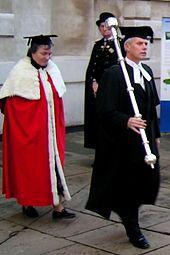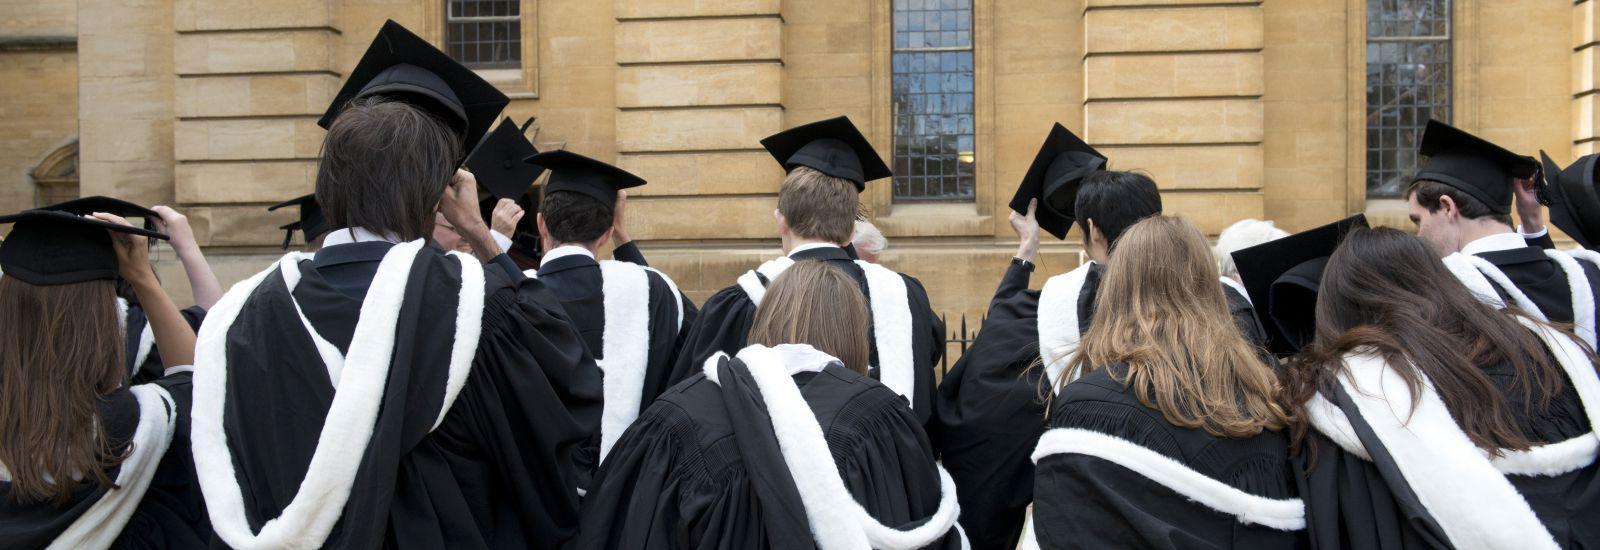The first image is the image on the left, the second image is the image on the right. Given the left and right images, does the statement "The left image contains at least 4 students in gowns, and you can see their entire body, head to foot." hold true? Answer yes or no. No. The first image is the image on the left, the second image is the image on the right. Assess this claim about the two images: "One photo has at least one male wearing a purple tie that is visible.". Correct or not? Answer yes or no. No. 